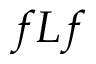Convert formula to latex. <formula><loc_0><loc_0><loc_500><loc_500>f L f</formula> 